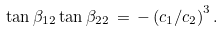Convert formula to latex. <formula><loc_0><loc_0><loc_500><loc_500>\tan \beta _ { 1 2 } \tan \beta _ { 2 2 } \, = \, - \left ( c _ { 1 } / c _ { 2 } \right ) ^ { 3 } .</formula> 